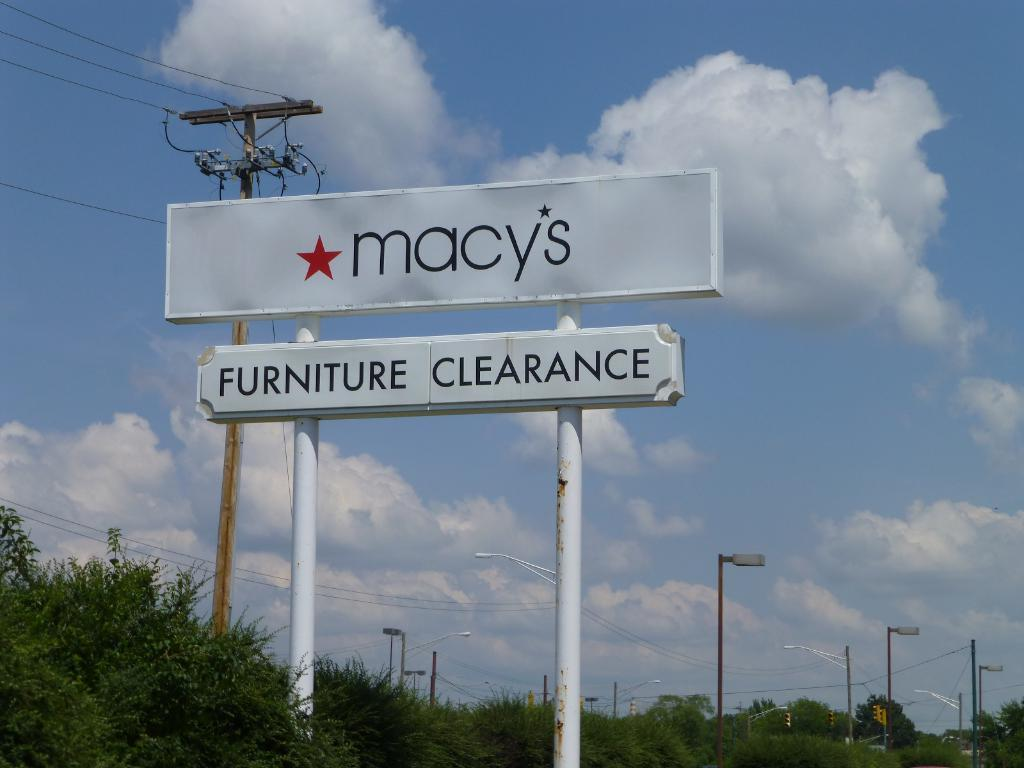Provide a one-sentence caption for the provided image. A weathered store sign for Macy's store stands tall in front of a blue sky. 